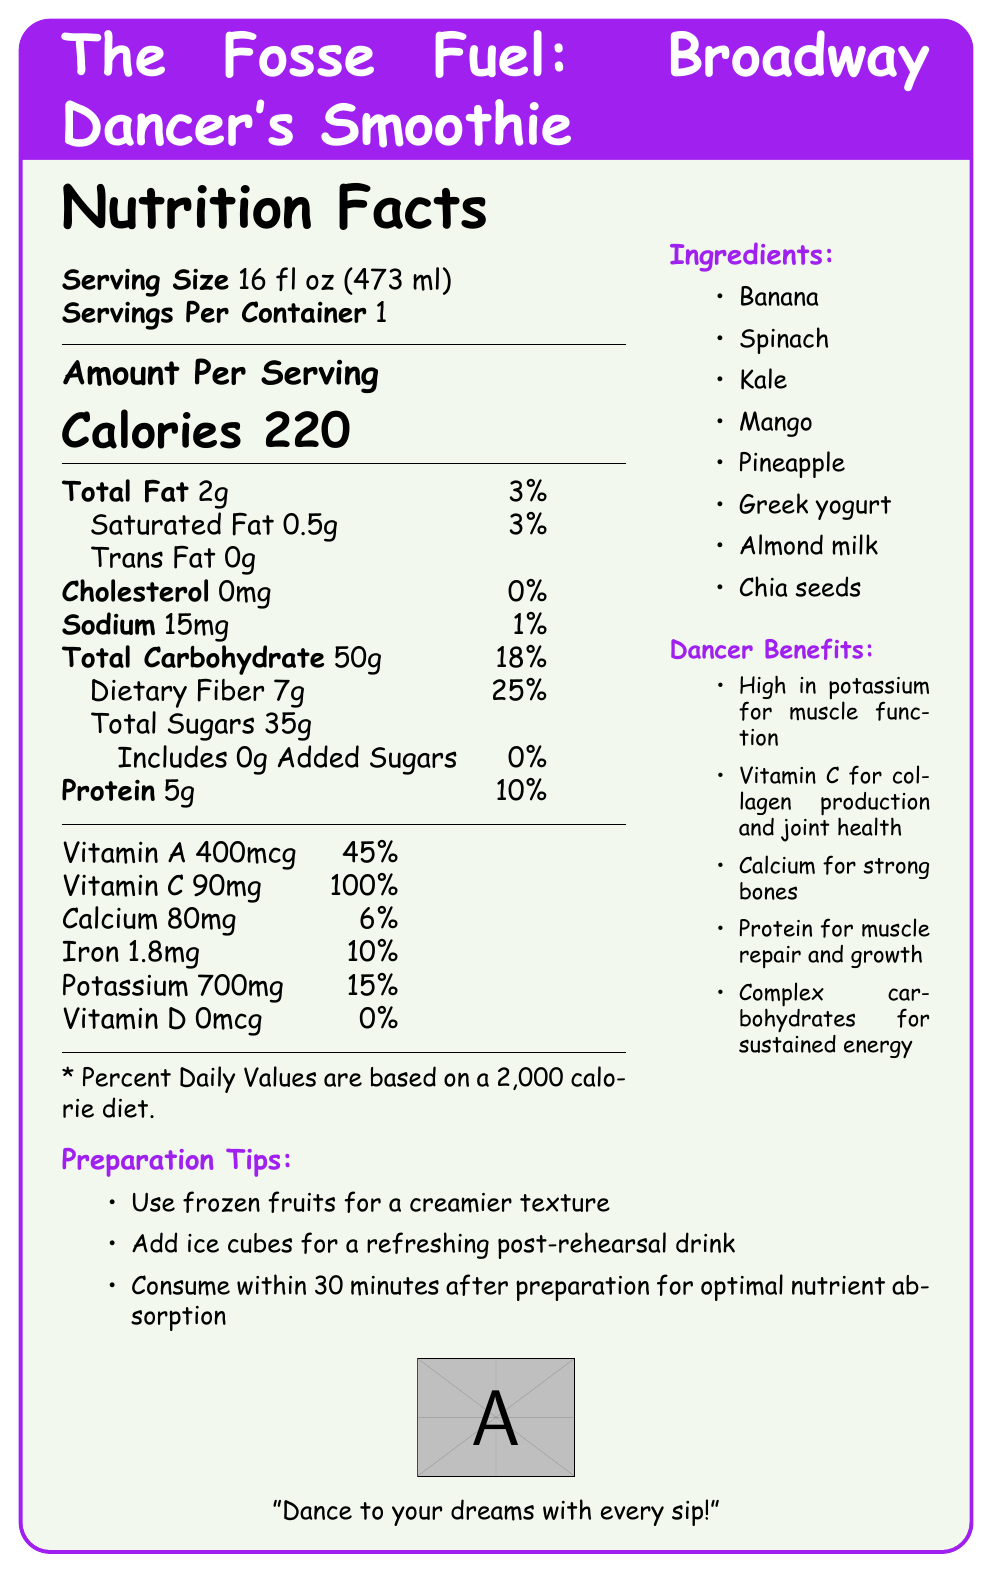what is the serving size of the smoothie? The serving size is clearly labeled as 16 fl oz (473 ml) in the document.
Answer: 16 fl oz (473 ml) how many calories are in one serving? The number of calories is listed as 220 per serving in the document.
Answer: 220 what is the percentage of daily value for vitamin C? The daily value percentage for vitamin C is indicated as 100% in the document.
Answer: 100% what are the main ingredients of the smoothie? The ingredients are listed in the document's ingredients section.
Answer: Banana, Spinach, Kale, Mango, Pineapple, Greek yogurt, Almond milk, Chia seeds how much protein does one serving of this smoothie provide? The amount of protein provided per serving is 5g, as shown in the document.
Answer: 5g compared to the daily recommended amount, how much calcium does one serving provide? The document states the calcium content as 80mg, which is 6% of the daily recommended intake.
Answer: 6% which of the following is a primary benefit for dancers from this smoothie? A. Rich in vitamin D B. High in potassium C. Low in sodium D. Low in calories The document mentions "High in potassium for muscle function" as a benefit for dancers.
Answer: B what type of milk is used in the smoothie? A. Whole milk B. Skimmed milk C. Almond milk D. Soy milk Almond milk is listed as one of the ingredients.
Answer: C does this smoothie contain any trans fat? The document indicates that the amount of trans fat is 0g.
Answer: No is the smoothie recommended to consume immediately after preparation? The document suggests consuming the smoothie within 30 minutes after preparation for optimal nutrient absorption.
Answer: Yes summarize the main idea of the document. The overall intention of the document is to present the nutritional values and benefits of the smoothie named "The Fosse Fuel", recommended for dancers, alongside preparation and consumption tips.
Answer: The document provides a nutritional breakdown of "The Fosse Fuel" smoothie, detailing its serving size, caloric content, macronutrients, vitamins, minerals, ingredients, benefits for dancers, and preparation tips. It emphasizes its high potassium, vitamin C, calcium, and protein content, along with preparation suggestions to enhance texture and refreshment. how much total carbohydrate is present in one serving? The amount of total carbohydrates per serving is listed as 50g in the document.
Answer: 50g does the smoothie contain any added sugars? There are 0g of added sugars in the smoothie according to the document.
Answer: No what deficiency might this smoothie not help with based on its nutrients? The document shows that the smoothie contains 0mcg of vitamin D, meaning it would not help with a vitamin D deficiency.
Answer: Vitamin D deficiency what day of the week is best to consume this smoothie? The document does not provide any information related to the best day of the week to consume the smoothie.
Answer: Not enough information 